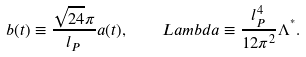<formula> <loc_0><loc_0><loc_500><loc_500>b ( t ) \equiv \frac { \sqrt { 2 4 } \pi } { l _ { P } } a ( t ) , \quad L a m b d a \equiv \frac { l _ { P } ^ { 4 } } { 1 2 \pi ^ { 2 } } \Lambda ^ { ^ { * } } .</formula> 